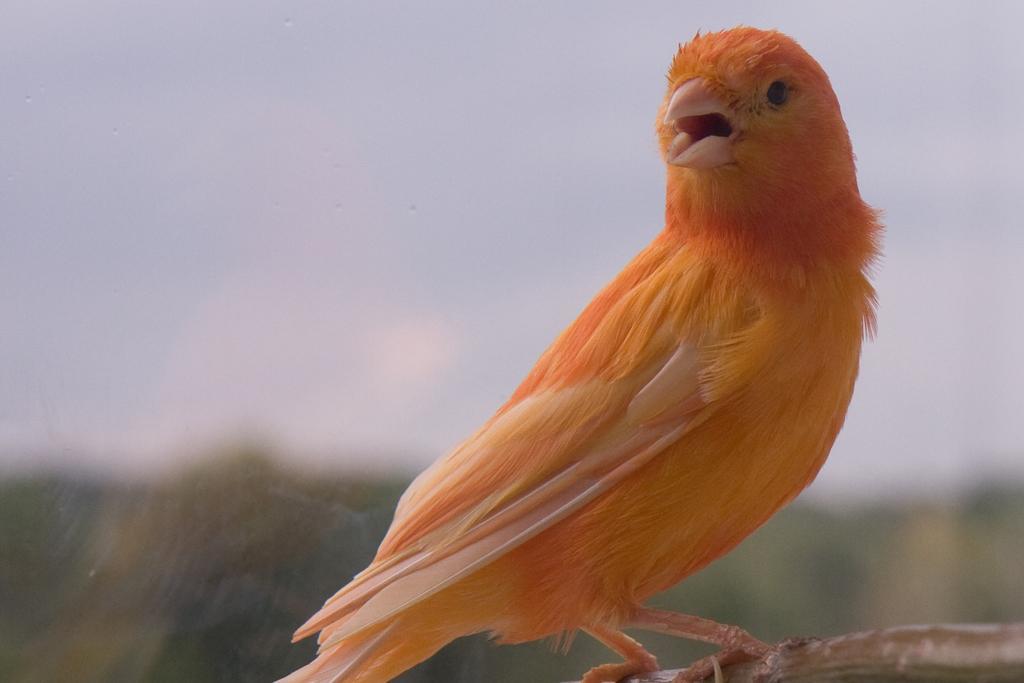How would you summarize this image in a sentence or two? Here we can see bird on this system. Background it is blur. 